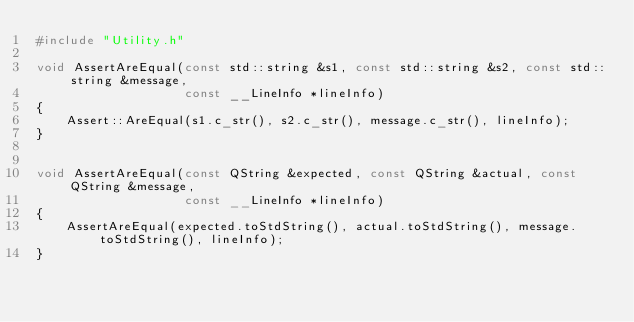Convert code to text. <code><loc_0><loc_0><loc_500><loc_500><_C++_>#include "Utility.h"

void AssertAreEqual(const std::string &s1, const std::string &s2, const std::string &message,
					const __LineInfo *lineInfo)
{
	Assert::AreEqual(s1.c_str(), s2.c_str(), message.c_str(), lineInfo);
}


void AssertAreEqual(const QString &expected, const QString &actual, const QString &message,
					const __LineInfo *lineInfo)
{
	AssertAreEqual(expected.toStdString(), actual.toStdString(), message.toStdString(), lineInfo);
}</code> 